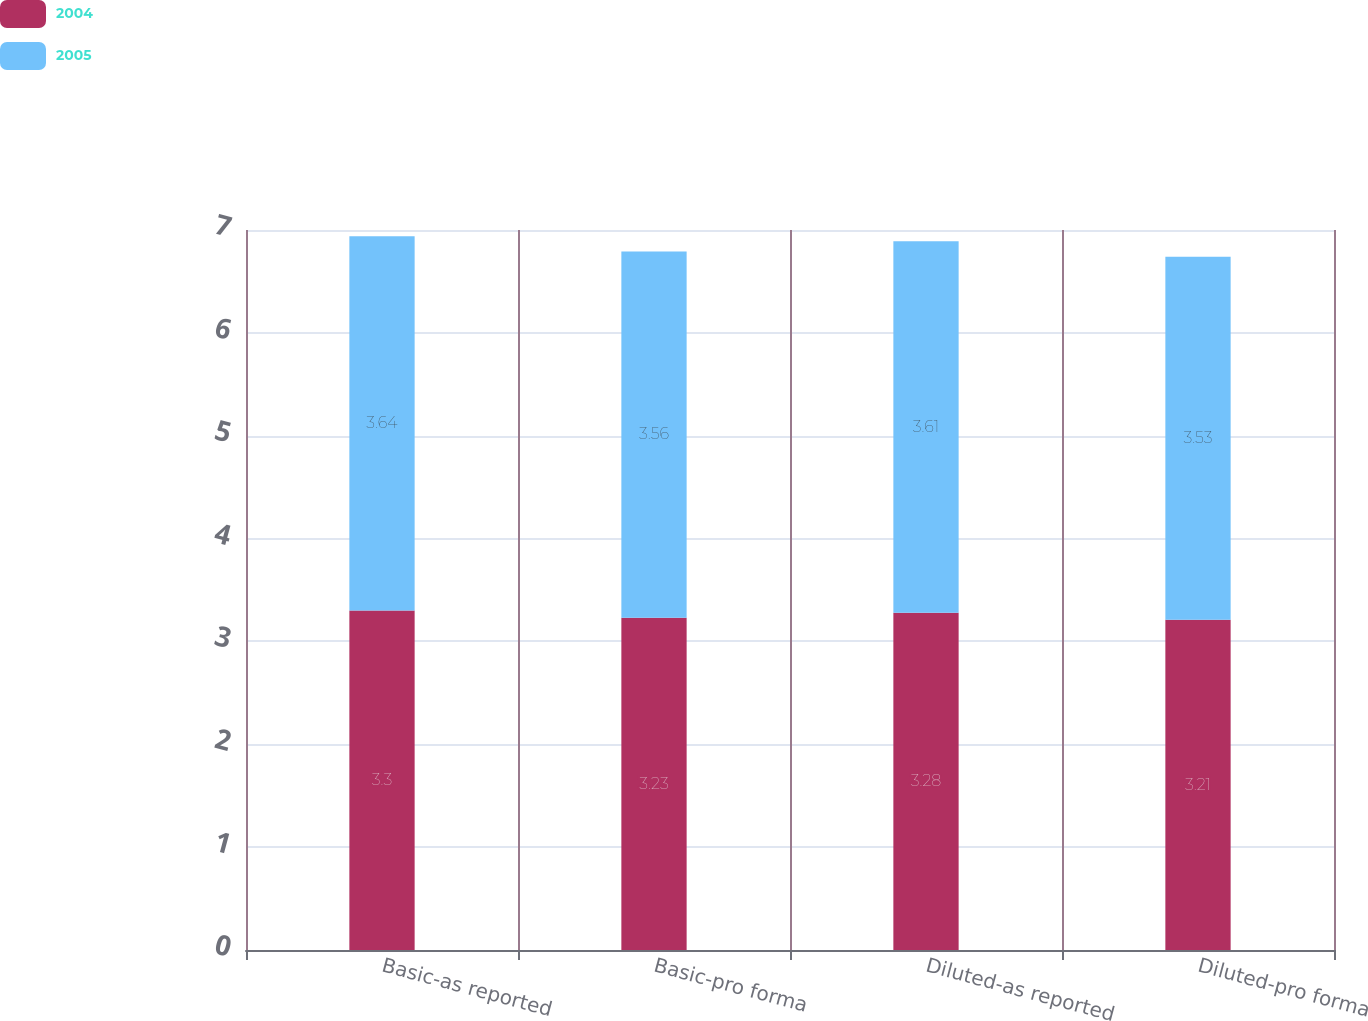Convert chart. <chart><loc_0><loc_0><loc_500><loc_500><stacked_bar_chart><ecel><fcel>Basic-as reported<fcel>Basic-pro forma<fcel>Diluted-as reported<fcel>Diluted-pro forma<nl><fcel>2004<fcel>3.3<fcel>3.23<fcel>3.28<fcel>3.21<nl><fcel>2005<fcel>3.64<fcel>3.56<fcel>3.61<fcel>3.53<nl></chart> 